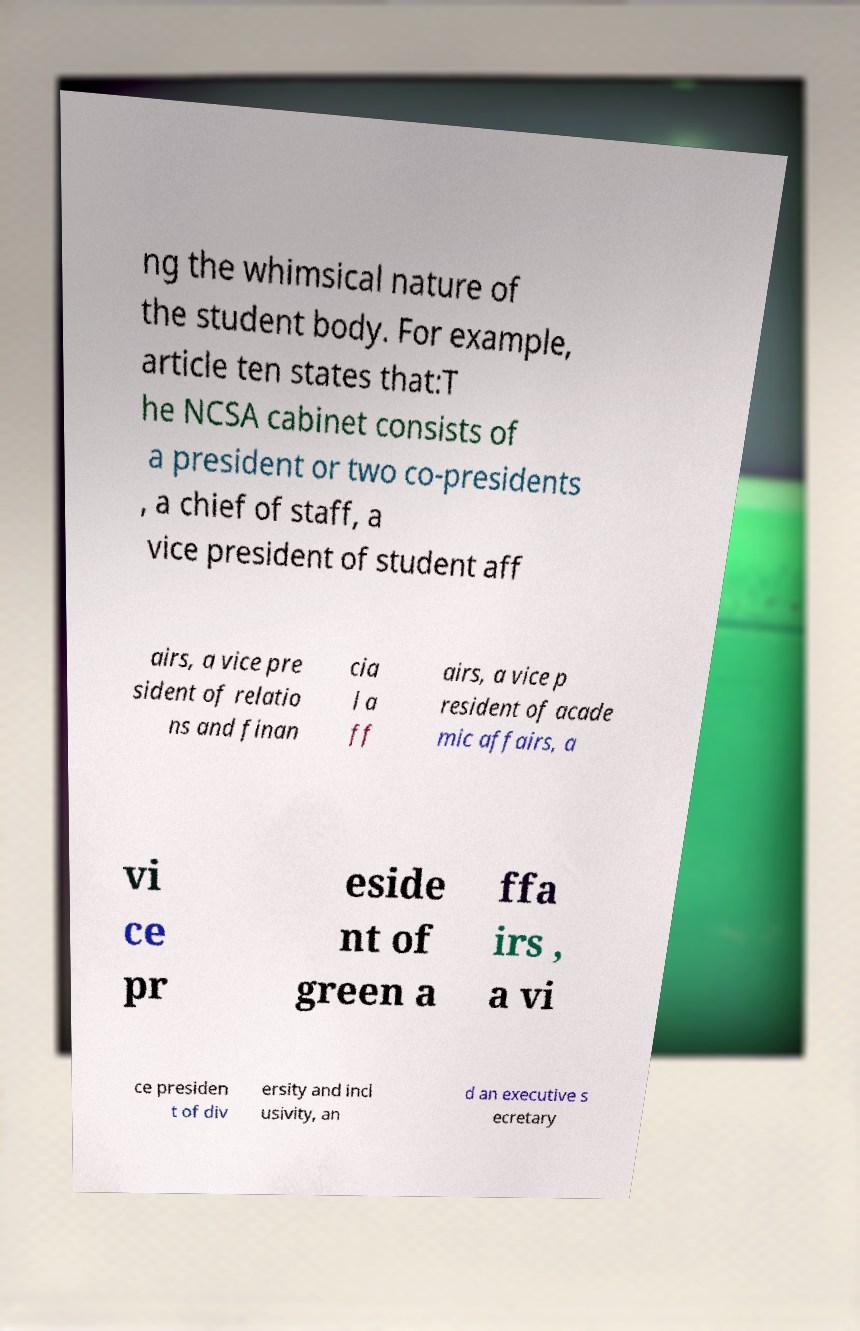There's text embedded in this image that I need extracted. Can you transcribe it verbatim? ng the whimsical nature of the student body. For example, article ten states that:T he NCSA cabinet consists of a president or two co-presidents , a chief of staff, a vice president of student aff airs, a vice pre sident of relatio ns and finan cia l a ff airs, a vice p resident of acade mic affairs, a vi ce pr eside nt of green a ffa irs , a vi ce presiden t of div ersity and incl usivity, an d an executive s ecretary 